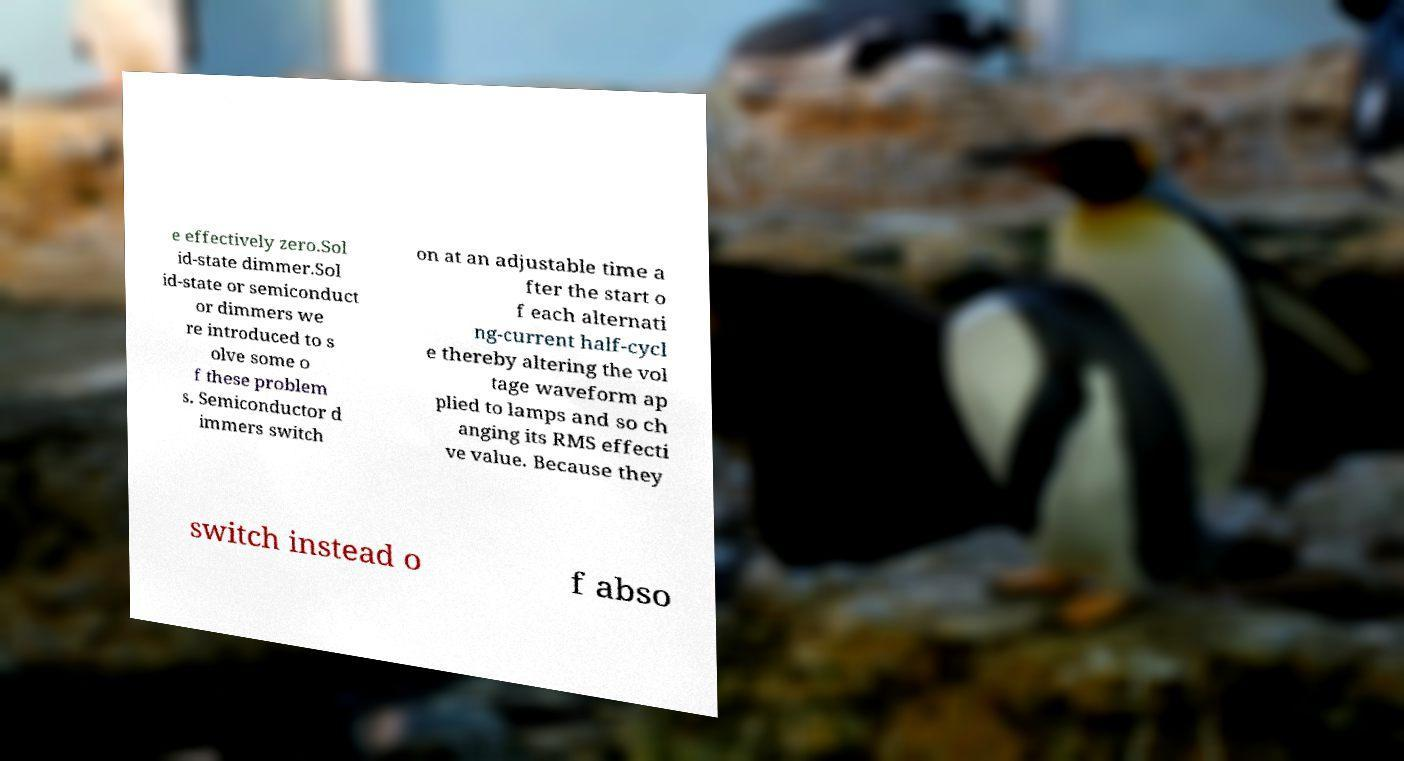Can you accurately transcribe the text from the provided image for me? e effectively zero.Sol id-state dimmer.Sol id-state or semiconduct or dimmers we re introduced to s olve some o f these problem s. Semiconductor d immers switch on at an adjustable time a fter the start o f each alternati ng-current half-cycl e thereby altering the vol tage waveform ap plied to lamps and so ch anging its RMS effecti ve value. Because they switch instead o f abso 